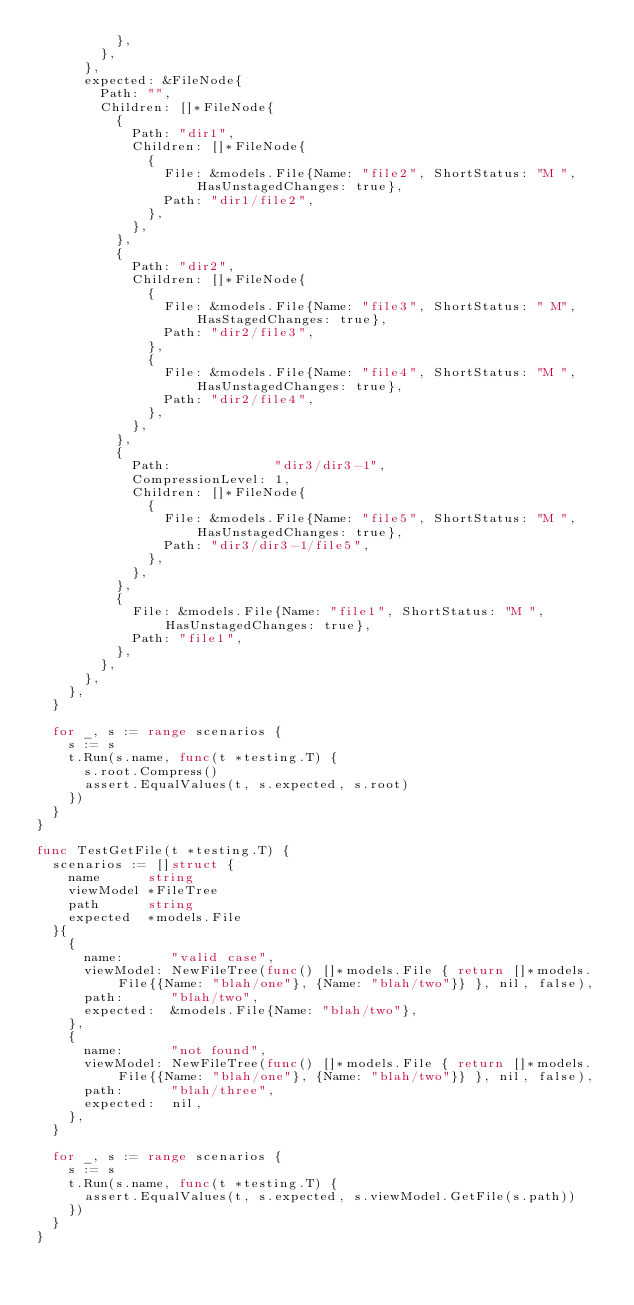<code> <loc_0><loc_0><loc_500><loc_500><_Go_>					},
				},
			},
			expected: &FileNode{
				Path: "",
				Children: []*FileNode{
					{
						Path: "dir1",
						Children: []*FileNode{
							{
								File: &models.File{Name: "file2", ShortStatus: "M ", HasUnstagedChanges: true},
								Path: "dir1/file2",
							},
						},
					},
					{
						Path: "dir2",
						Children: []*FileNode{
							{
								File: &models.File{Name: "file3", ShortStatus: " M", HasStagedChanges: true},
								Path: "dir2/file3",
							},
							{
								File: &models.File{Name: "file4", ShortStatus: "M ", HasUnstagedChanges: true},
								Path: "dir2/file4",
							},
						},
					},
					{
						Path:             "dir3/dir3-1",
						CompressionLevel: 1,
						Children: []*FileNode{
							{
								File: &models.File{Name: "file5", ShortStatus: "M ", HasUnstagedChanges: true},
								Path: "dir3/dir3-1/file5",
							},
						},
					},
					{
						File: &models.File{Name: "file1", ShortStatus: "M ", HasUnstagedChanges: true},
						Path: "file1",
					},
				},
			},
		},
	}

	for _, s := range scenarios {
		s := s
		t.Run(s.name, func(t *testing.T) {
			s.root.Compress()
			assert.EqualValues(t, s.expected, s.root)
		})
	}
}

func TestGetFile(t *testing.T) {
	scenarios := []struct {
		name      string
		viewModel *FileTree
		path      string
		expected  *models.File
	}{
		{
			name:      "valid case",
			viewModel: NewFileTree(func() []*models.File { return []*models.File{{Name: "blah/one"}, {Name: "blah/two"}} }, nil, false),
			path:      "blah/two",
			expected:  &models.File{Name: "blah/two"},
		},
		{
			name:      "not found",
			viewModel: NewFileTree(func() []*models.File { return []*models.File{{Name: "blah/one"}, {Name: "blah/two"}} }, nil, false),
			path:      "blah/three",
			expected:  nil,
		},
	}

	for _, s := range scenarios {
		s := s
		t.Run(s.name, func(t *testing.T) {
			assert.EqualValues(t, s.expected, s.viewModel.GetFile(s.path))
		})
	}
}
</code> 